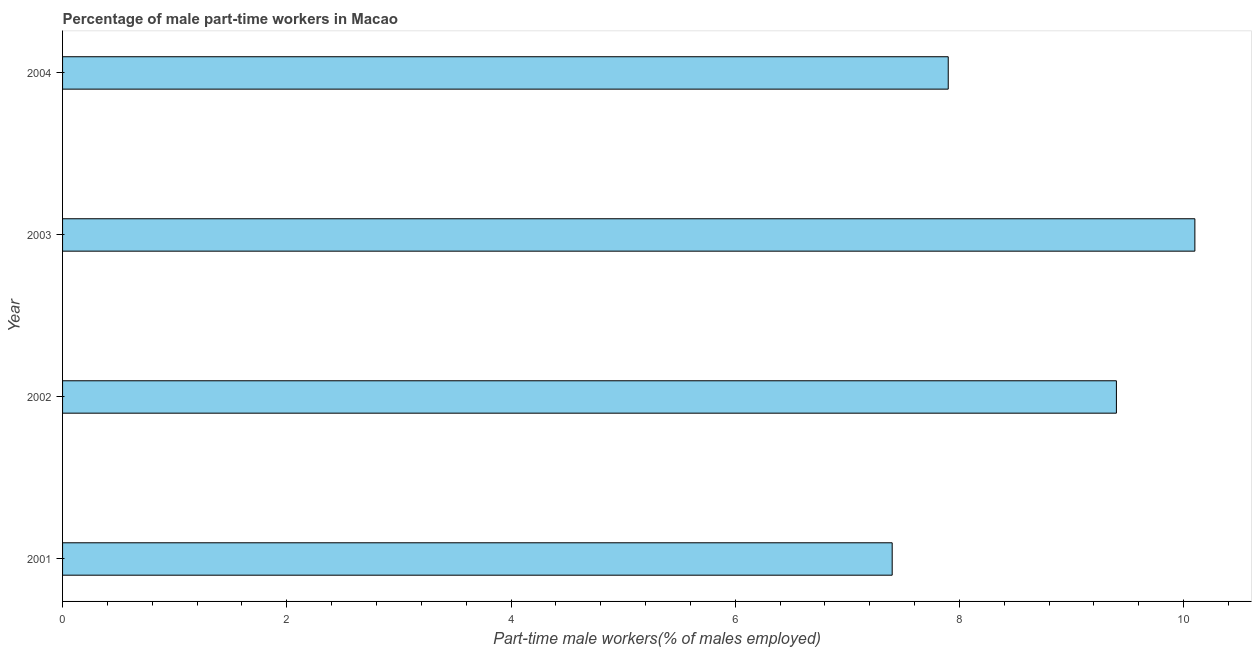Does the graph contain any zero values?
Ensure brevity in your answer.  No. Does the graph contain grids?
Keep it short and to the point. No. What is the title of the graph?
Provide a short and direct response. Percentage of male part-time workers in Macao. What is the label or title of the X-axis?
Make the answer very short. Part-time male workers(% of males employed). What is the percentage of part-time male workers in 2001?
Offer a very short reply. 7.4. Across all years, what is the maximum percentage of part-time male workers?
Your response must be concise. 10.1. Across all years, what is the minimum percentage of part-time male workers?
Keep it short and to the point. 7.4. What is the sum of the percentage of part-time male workers?
Offer a very short reply. 34.8. What is the median percentage of part-time male workers?
Give a very brief answer. 8.65. In how many years, is the percentage of part-time male workers greater than 9.2 %?
Your response must be concise. 2. Do a majority of the years between 2003 and 2004 (inclusive) have percentage of part-time male workers greater than 9.6 %?
Your answer should be very brief. No. What is the ratio of the percentage of part-time male workers in 2001 to that in 2002?
Provide a short and direct response. 0.79. Is the difference between the percentage of part-time male workers in 2001 and 2004 greater than the difference between any two years?
Your response must be concise. No. In how many years, is the percentage of part-time male workers greater than the average percentage of part-time male workers taken over all years?
Offer a terse response. 2. How many bars are there?
Ensure brevity in your answer.  4. Are all the bars in the graph horizontal?
Your answer should be compact. Yes. Are the values on the major ticks of X-axis written in scientific E-notation?
Keep it short and to the point. No. What is the Part-time male workers(% of males employed) of 2001?
Offer a terse response. 7.4. What is the Part-time male workers(% of males employed) of 2002?
Ensure brevity in your answer.  9.4. What is the Part-time male workers(% of males employed) of 2003?
Make the answer very short. 10.1. What is the Part-time male workers(% of males employed) of 2004?
Provide a short and direct response. 7.9. What is the difference between the Part-time male workers(% of males employed) in 2001 and 2003?
Provide a succinct answer. -2.7. What is the difference between the Part-time male workers(% of males employed) in 2001 and 2004?
Give a very brief answer. -0.5. What is the difference between the Part-time male workers(% of males employed) in 2002 and 2004?
Ensure brevity in your answer.  1.5. What is the ratio of the Part-time male workers(% of males employed) in 2001 to that in 2002?
Provide a short and direct response. 0.79. What is the ratio of the Part-time male workers(% of males employed) in 2001 to that in 2003?
Provide a short and direct response. 0.73. What is the ratio of the Part-time male workers(% of males employed) in 2001 to that in 2004?
Keep it short and to the point. 0.94. What is the ratio of the Part-time male workers(% of males employed) in 2002 to that in 2003?
Offer a terse response. 0.93. What is the ratio of the Part-time male workers(% of males employed) in 2002 to that in 2004?
Your answer should be compact. 1.19. What is the ratio of the Part-time male workers(% of males employed) in 2003 to that in 2004?
Make the answer very short. 1.28. 